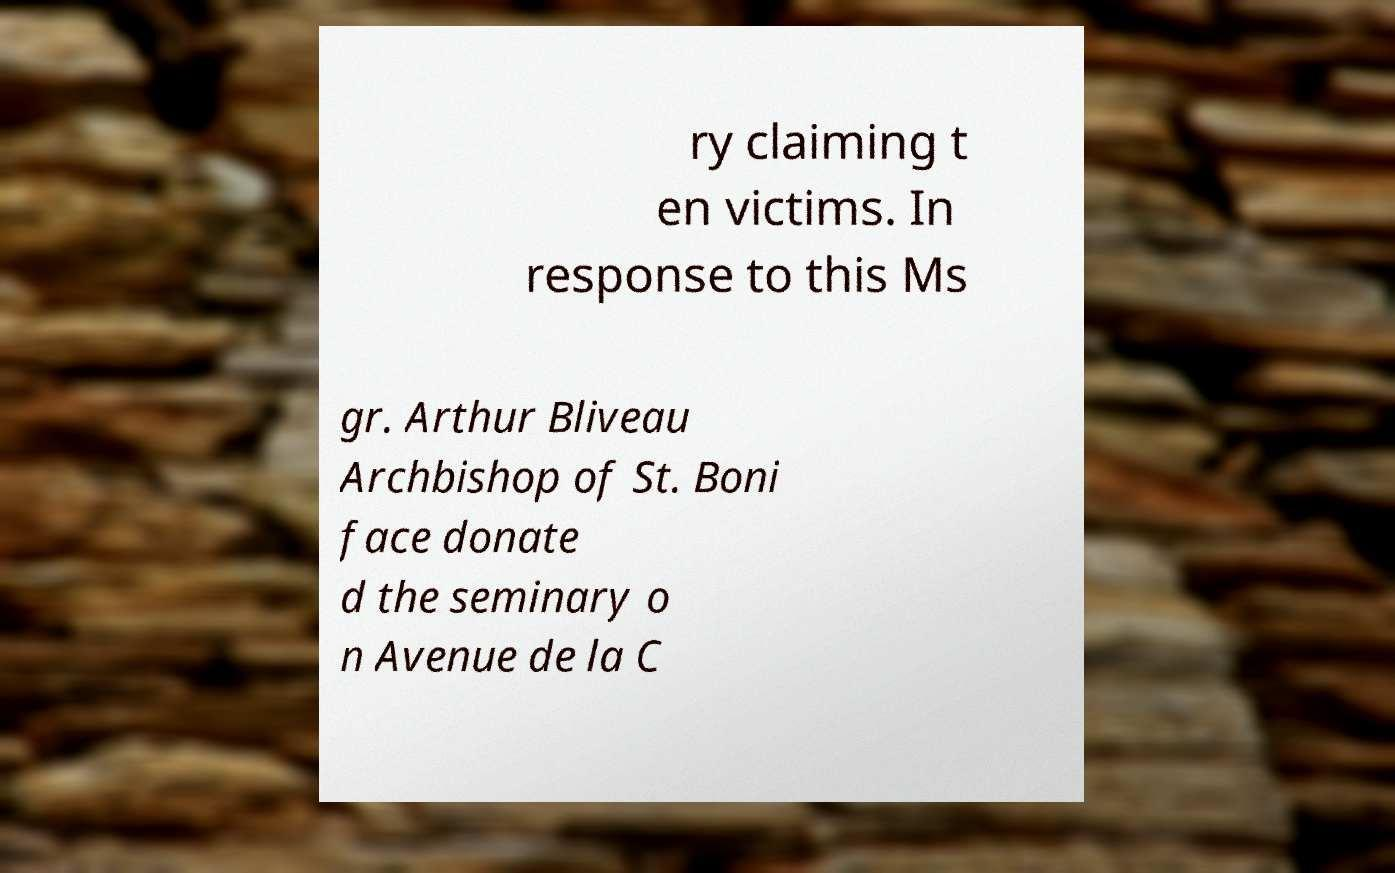Can you accurately transcribe the text from the provided image for me? ry claiming t en victims. In response to this Ms gr. Arthur Bliveau Archbishop of St. Boni face donate d the seminary o n Avenue de la C 